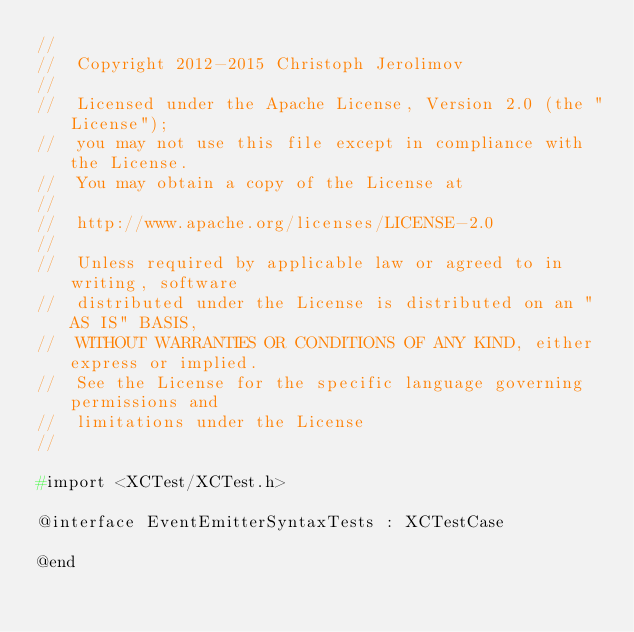<code> <loc_0><loc_0><loc_500><loc_500><_C_>//
//  Copyright 2012-2015 Christoph Jerolimov
//
//  Licensed under the Apache License, Version 2.0 (the "License");
//  you may not use this file except in compliance with the License.
//  You may obtain a copy of the License at
//
//  http://www.apache.org/licenses/LICENSE-2.0
//
//  Unless required by applicable law or agreed to in writing, software
//  distributed under the License is distributed on an "AS IS" BASIS,
//  WITHOUT WARRANTIES OR CONDITIONS OF ANY KIND, either express or implied.
//  See the License for the specific language governing permissions and
//  limitations under the License
//

#import <XCTest/XCTest.h>

@interface EventEmitterSyntaxTests : XCTestCase

@end
</code> 